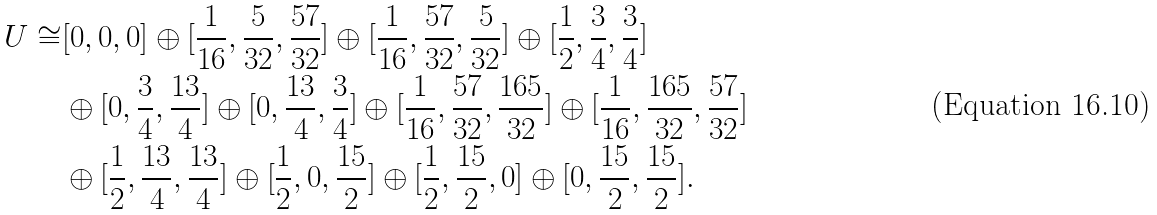<formula> <loc_0><loc_0><loc_500><loc_500>U \cong & [ 0 , 0 , 0 ] \oplus [ \frac { 1 } { 1 6 } , \frac { 5 } { 3 2 } , \frac { 5 7 } { 3 2 } ] \oplus [ \frac { 1 } { 1 6 } , \frac { 5 7 } { 3 2 } , \frac { 5 } { 3 2 } ] \oplus [ \frac { 1 } { 2 } , \frac { 3 } { 4 } , \frac { 3 } { 4 } ] \\ & \oplus [ 0 , \frac { 3 } { 4 } , \frac { 1 3 } { 4 } ] \oplus [ 0 , \frac { 1 3 } { 4 } , \frac { 3 } { 4 } ] \oplus [ \frac { 1 } { 1 6 } , \frac { 5 7 } { 3 2 } , \frac { 1 6 5 } { 3 2 } ] \oplus [ \frac { 1 } { 1 6 } , \frac { 1 6 5 } { 3 2 } , \frac { 5 7 } { 3 2 } ] \\ & \oplus [ \frac { 1 } { 2 } , \frac { 1 3 } { 4 } , \frac { 1 3 } { 4 } ] \oplus [ \frac { 1 } { 2 } , 0 , \frac { 1 5 } { 2 } ] \oplus [ \frac { 1 } { 2 } , \frac { 1 5 } { 2 } , 0 ] \oplus [ 0 , \frac { 1 5 } { 2 } , \frac { 1 5 } { 2 } ] .</formula> 